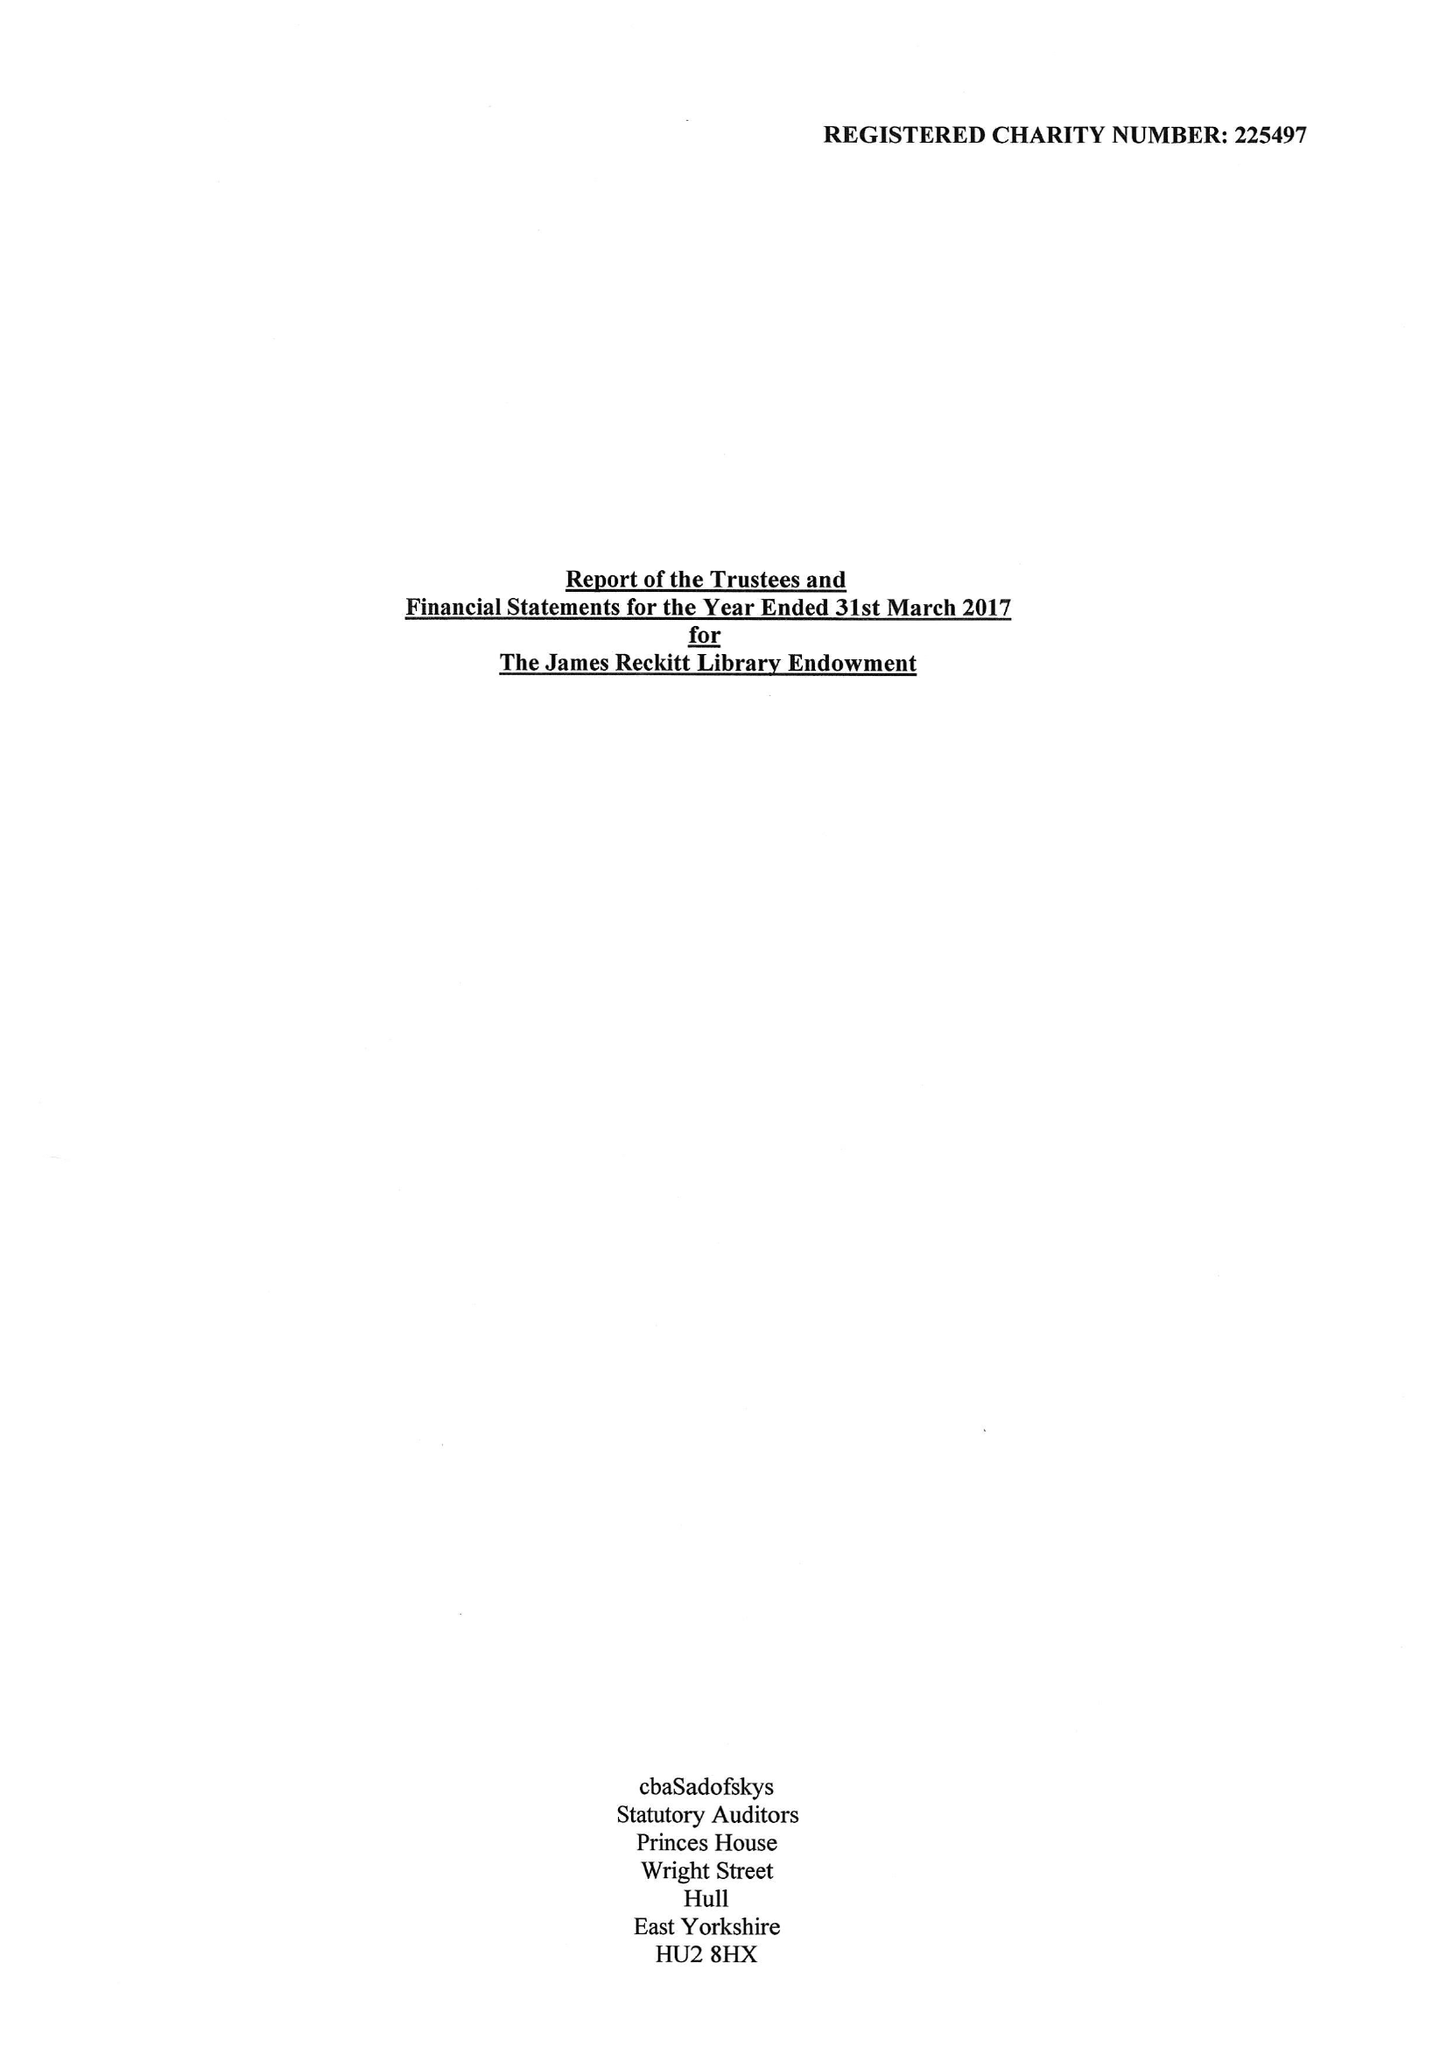What is the value for the income_annually_in_british_pounds?
Answer the question using a single word or phrase. 432917.00 